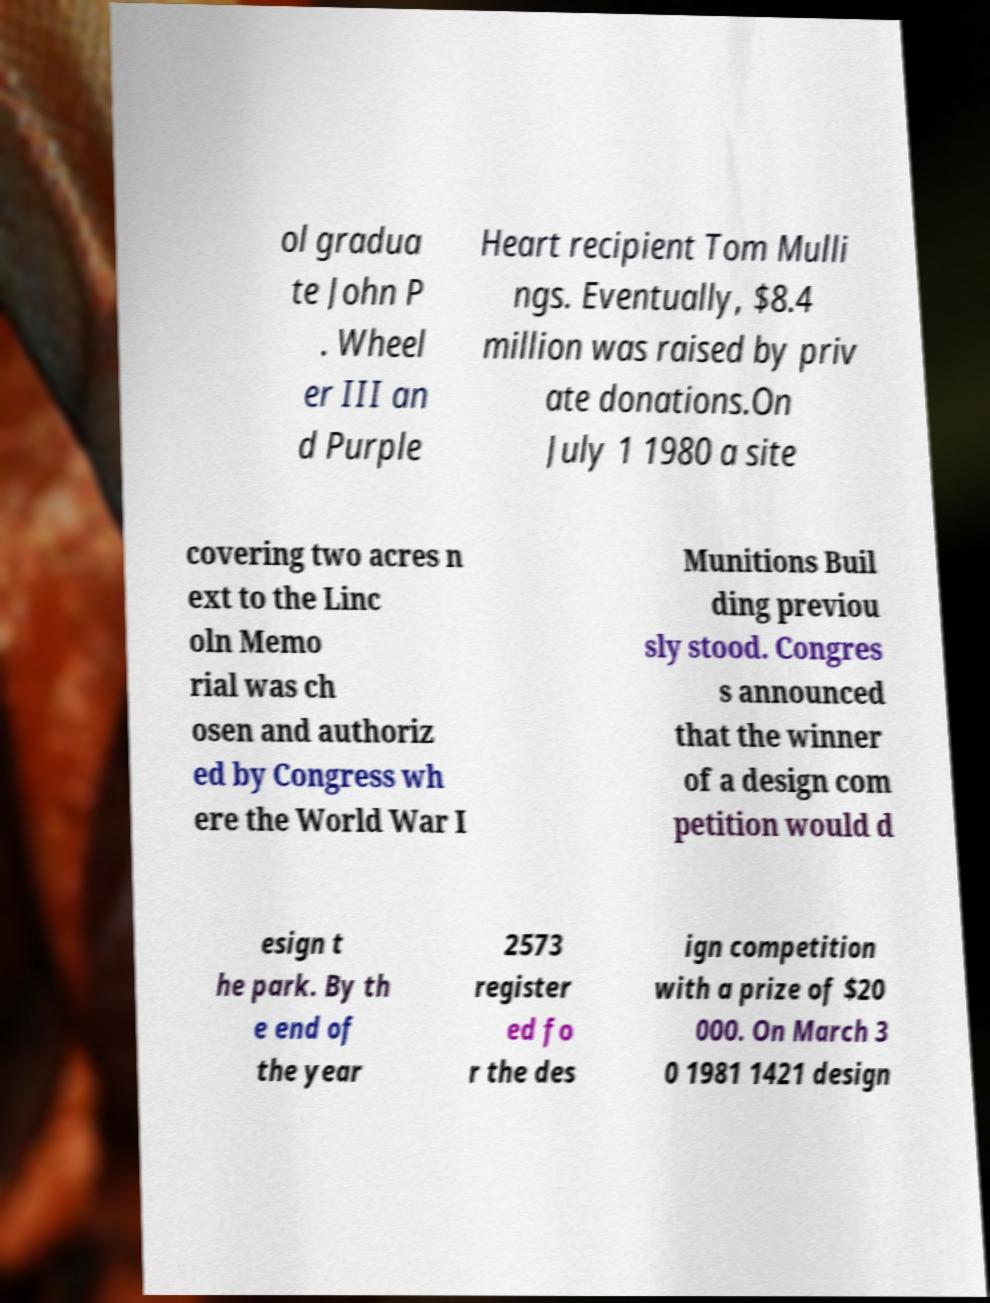There's text embedded in this image that I need extracted. Can you transcribe it verbatim? ol gradua te John P . Wheel er III an d Purple Heart recipient Tom Mulli ngs. Eventually, $8.4 million was raised by priv ate donations.On July 1 1980 a site covering two acres n ext to the Linc oln Memo rial was ch osen and authoriz ed by Congress wh ere the World War I Munitions Buil ding previou sly stood. Congres s announced that the winner of a design com petition would d esign t he park. By th e end of the year 2573 register ed fo r the des ign competition with a prize of $20 000. On March 3 0 1981 1421 design 